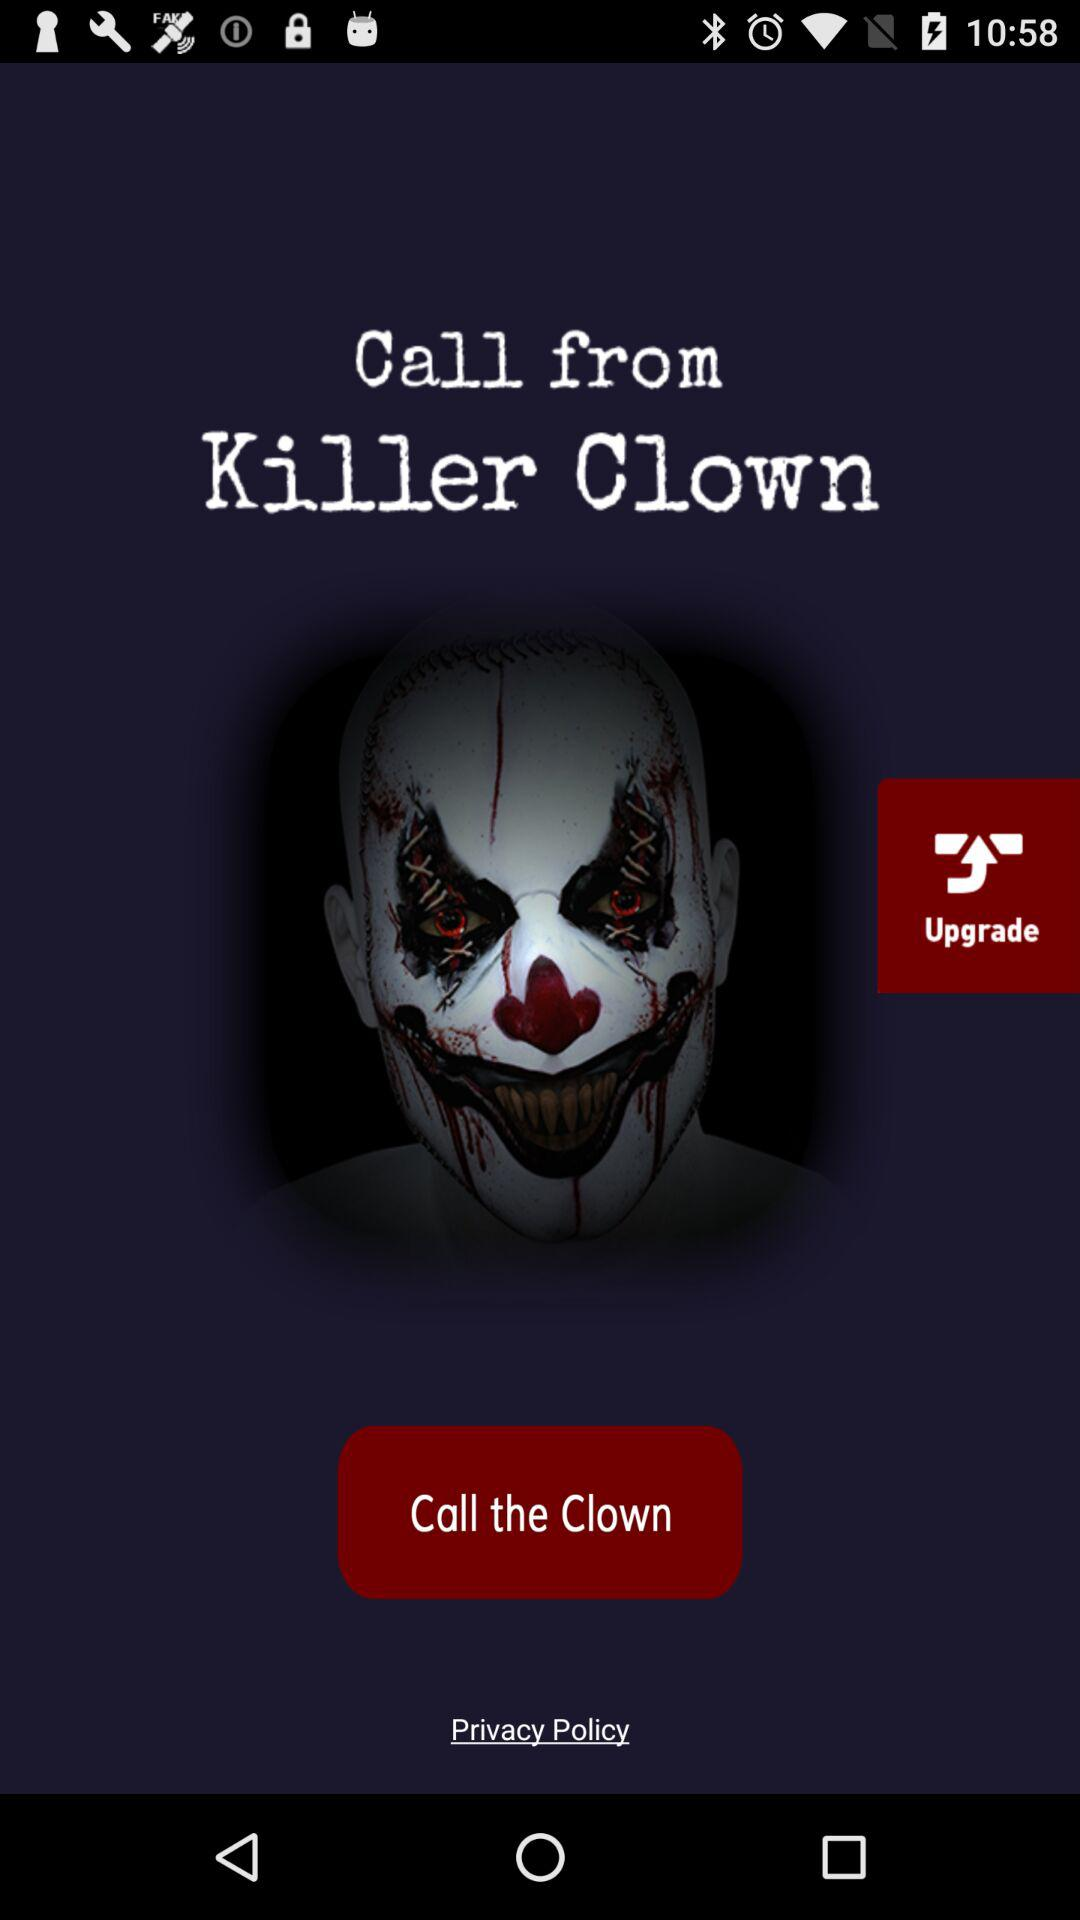What is the name of the application? The name of the application is "Call from Killer Clown". 